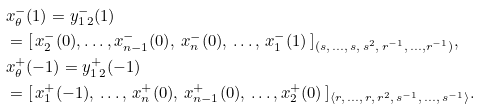<formula> <loc_0><loc_0><loc_500><loc_500>& x ^ { - } _ { \theta } ( 1 ) = y _ { 1 \, 2 } ^ { - } ( 1 ) \\ & = [ \, x _ { 2 } ^ { - } ( 0 ) , \dots , x _ { n - 1 } ^ { - } ( 0 ) , \, x _ { n } ^ { - } ( 0 ) , \, \dots , \, x _ { 1 } ^ { - } ( 1 ) \, ] _ { ( s , \, \dots , \, s , \, s ^ { 2 } , \, r ^ { - 1 } , \, \dots , r ^ { - 1 } ) } , \\ & x _ { \theta } ^ { + } ( - 1 ) = y _ { 1 \, 2 } ^ { + } ( - 1 ) \\ & = [ \, x _ { 1 } ^ { + } ( - 1 ) , \, \dots , \, x _ { n } ^ { + } ( 0 ) , \, x _ { n - 1 } ^ { + } ( 0 ) , \, \dots , x _ { 2 } ^ { + } ( 0 ) \, ] _ { \langle r , \, \dots , \, r , \, r ^ { 2 } , \, s ^ { - 1 } , \, \dots , \, s ^ { - 1 } \rangle } .</formula> 